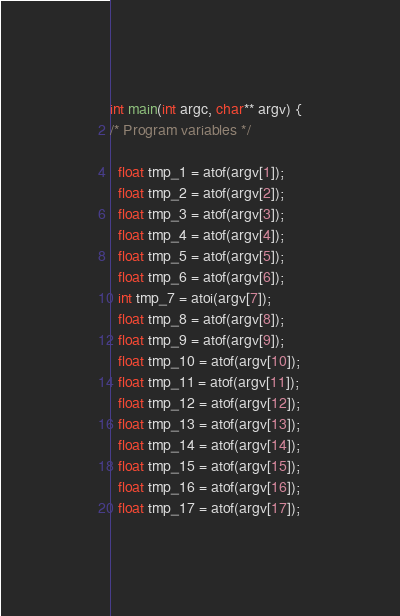<code> <loc_0><loc_0><loc_500><loc_500><_Cuda_>int main(int argc, char** argv) {
/* Program variables */

  float tmp_1 = atof(argv[1]);
  float tmp_2 = atof(argv[2]);
  float tmp_3 = atof(argv[3]);
  float tmp_4 = atof(argv[4]);
  float tmp_5 = atof(argv[5]);
  float tmp_6 = atof(argv[6]);
  int tmp_7 = atoi(argv[7]);
  float tmp_8 = atof(argv[8]);
  float tmp_9 = atof(argv[9]);
  float tmp_10 = atof(argv[10]);
  float tmp_11 = atof(argv[11]);
  float tmp_12 = atof(argv[12]);
  float tmp_13 = atof(argv[13]);
  float tmp_14 = atof(argv[14]);
  float tmp_15 = atof(argv[15]);
  float tmp_16 = atof(argv[16]);
  float tmp_17 = atof(argv[17]);</code> 